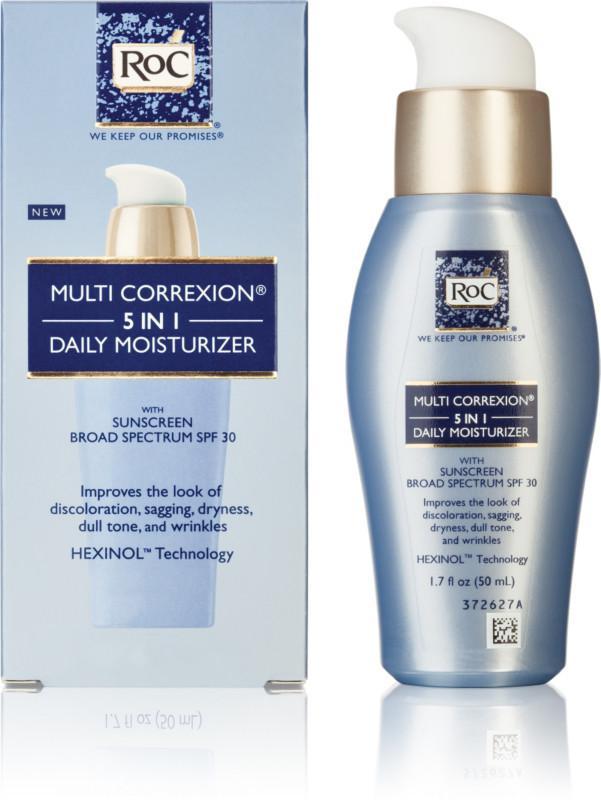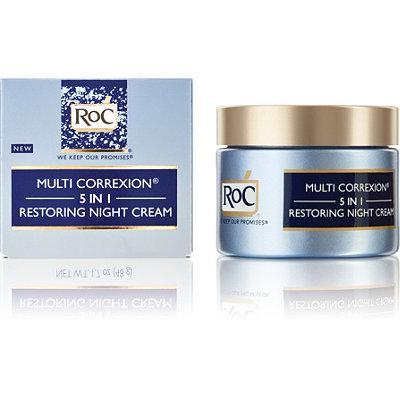The first image is the image on the left, the second image is the image on the right. Assess this claim about the two images: "Each image depicts one skincare product next to its box.". Correct or not? Answer yes or no. Yes. The first image is the image on the left, the second image is the image on the right. Assess this claim about the two images: "In each image, exactly one product is beside its box.". Correct or not? Answer yes or no. Yes. 